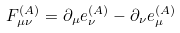<formula> <loc_0><loc_0><loc_500><loc_500>F _ { \mu \nu } ^ { ( A ) } = \partial _ { \mu } e _ { \nu } ^ { ( A ) } - \partial _ { \nu } e _ { \mu } ^ { ( A ) }</formula> 